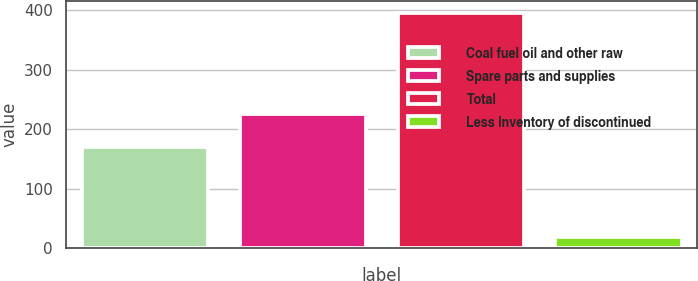Convert chart to OTSL. <chart><loc_0><loc_0><loc_500><loc_500><bar_chart><fcel>Coal fuel oil and other raw<fcel>Spare parts and supplies<fcel>Total<fcel>Less Inventory of discontinued<nl><fcel>171<fcel>225<fcel>396<fcel>20<nl></chart> 